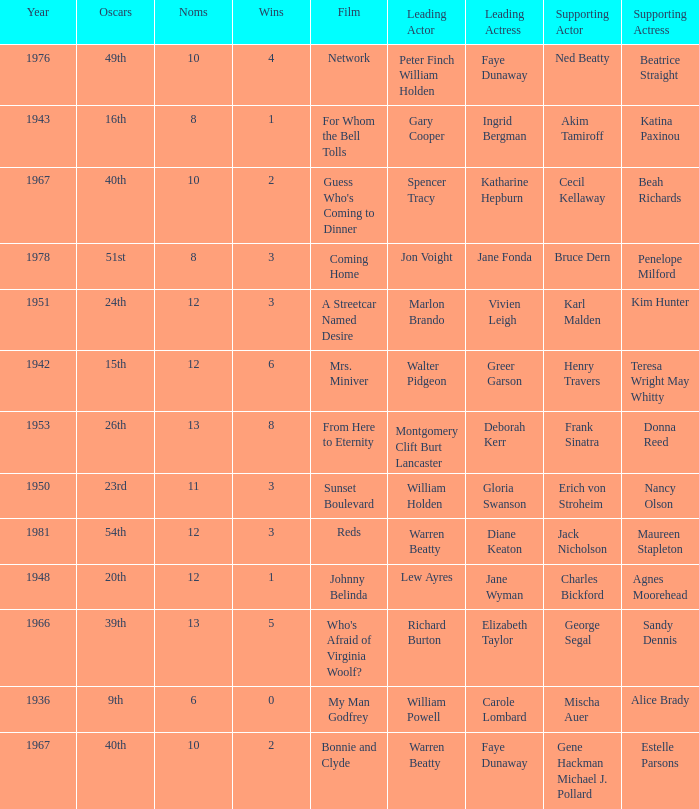Who was the leading actor in the film with a supporting actor named Cecil Kellaway? Spencer Tracy. Help me parse the entirety of this table. {'header': ['Year', 'Oscars', 'Noms', 'Wins', 'Film', 'Leading Actor', 'Leading Actress', 'Supporting Actor', 'Supporting Actress'], 'rows': [['1976', '49th', '10', '4', 'Network', 'Peter Finch William Holden', 'Faye Dunaway', 'Ned Beatty', 'Beatrice Straight'], ['1943', '16th', '8', '1', 'For Whom the Bell Tolls', 'Gary Cooper', 'Ingrid Bergman', 'Akim Tamiroff', 'Katina Paxinou'], ['1967', '40th', '10', '2', "Guess Who's Coming to Dinner", 'Spencer Tracy', 'Katharine Hepburn', 'Cecil Kellaway', 'Beah Richards'], ['1978', '51st', '8', '3', 'Coming Home', 'Jon Voight', 'Jane Fonda', 'Bruce Dern', 'Penelope Milford'], ['1951', '24th', '12', '3', 'A Streetcar Named Desire', 'Marlon Brando', 'Vivien Leigh', 'Karl Malden', 'Kim Hunter'], ['1942', '15th', '12', '6', 'Mrs. Miniver', 'Walter Pidgeon', 'Greer Garson', 'Henry Travers', 'Teresa Wright May Whitty'], ['1953', '26th', '13', '8', 'From Here to Eternity', 'Montgomery Clift Burt Lancaster', 'Deborah Kerr', 'Frank Sinatra', 'Donna Reed'], ['1950', '23rd', '11', '3', 'Sunset Boulevard', 'William Holden', 'Gloria Swanson', 'Erich von Stroheim', 'Nancy Olson'], ['1981', '54th', '12', '3', 'Reds', 'Warren Beatty', 'Diane Keaton', 'Jack Nicholson', 'Maureen Stapleton'], ['1948', '20th', '12', '1', 'Johnny Belinda', 'Lew Ayres', 'Jane Wyman', 'Charles Bickford', 'Agnes Moorehead'], ['1966', '39th', '13', '5', "Who's Afraid of Virginia Woolf?", 'Richard Burton', 'Elizabeth Taylor', 'George Segal', 'Sandy Dennis'], ['1936', '9th', '6', '0', 'My Man Godfrey', 'William Powell', 'Carole Lombard', 'Mischa Auer', 'Alice Brady'], ['1967', '40th', '10', '2', 'Bonnie and Clyde', 'Warren Beatty', 'Faye Dunaway', 'Gene Hackman Michael J. Pollard', 'Estelle Parsons']]} 